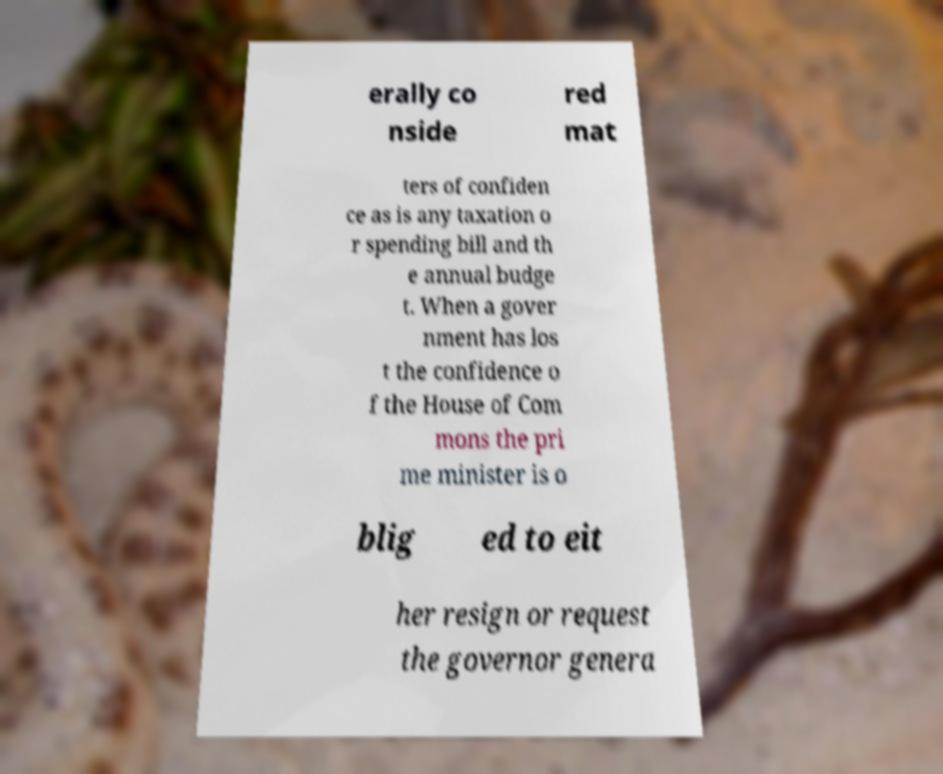Please read and relay the text visible in this image. What does it say? erally co nside red mat ters of confiden ce as is any taxation o r spending bill and th e annual budge t. When a gover nment has los t the confidence o f the House of Com mons the pri me minister is o blig ed to eit her resign or request the governor genera 